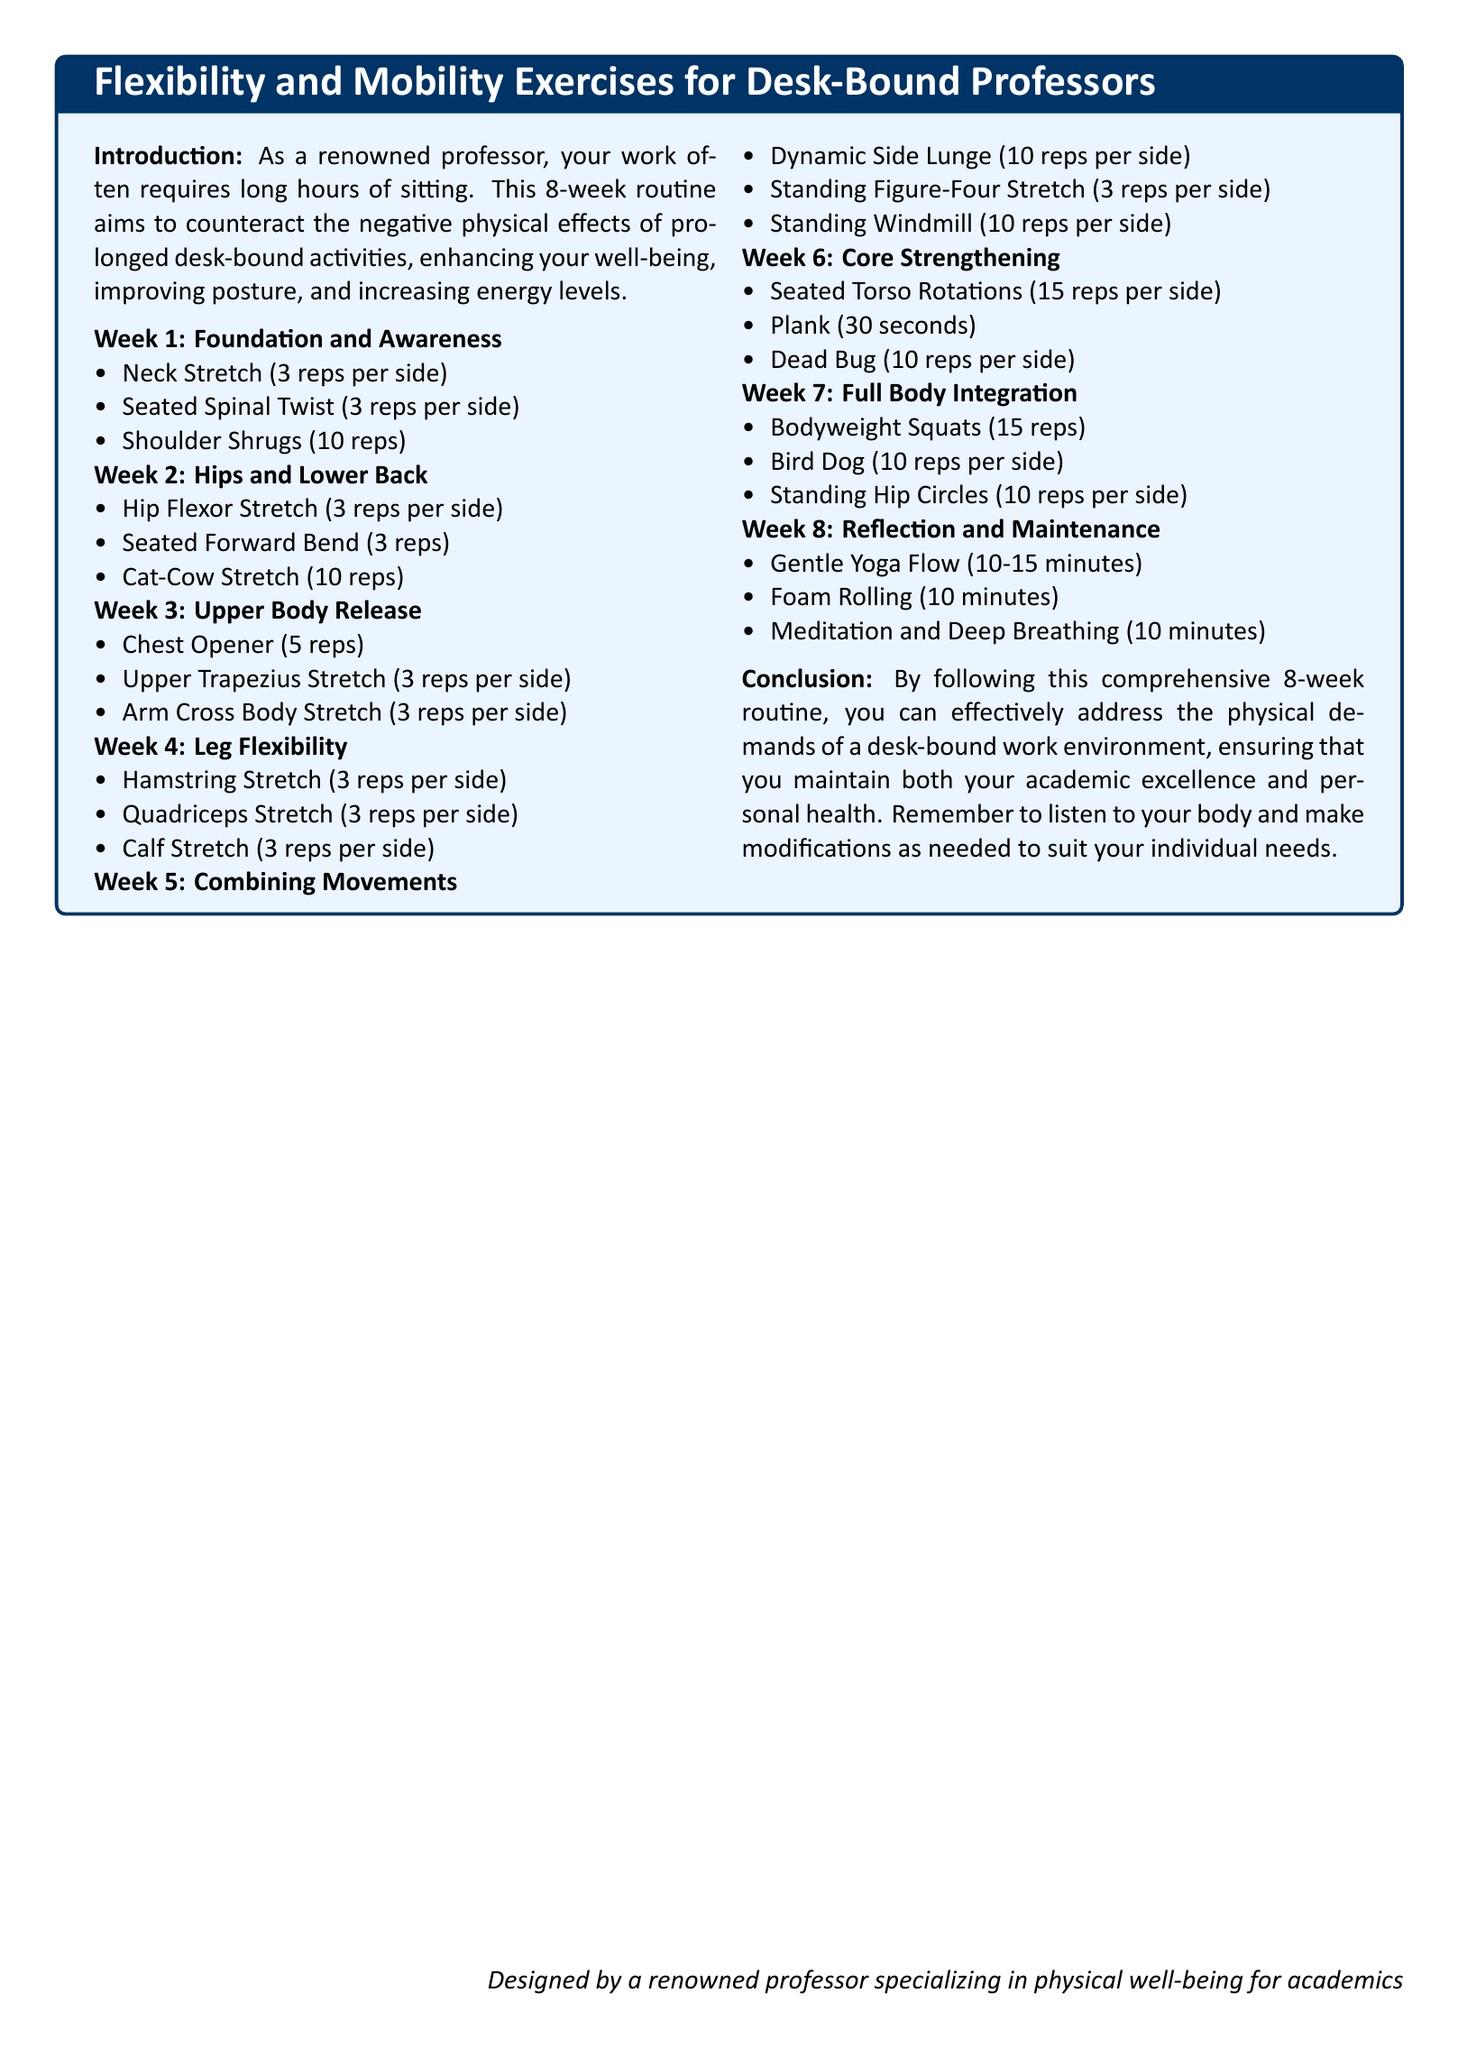What is the focus of the workout plan? The workout plan focuses on flexibility and mobility exercises for desk-bound professors.
Answer: Flexibility and mobility exercises How many weeks does the routine span? The document states that it is an 8-week routine.
Answer: 8 weeks What exercise is listed for Week 1? Week 1 includes the Neck Stretch as one of the exercises.
Answer: Neck Stretch How many reps are suggested for the Plank in Week 6? The Plank is suggested for a duration of 30 seconds in Week 6.
Answer: 30 seconds What is the main goal of the exercises in the plan? The main goal is to counteract negative physical effects of prolonged sitting.
Answer: Counteract negative physical effects of prolonged sitting Which week includes a Gentle Yoga Flow? The Gentle Yoga Flow is included in Week 8.
Answer: Week 8 What type of stretch is performed in Week 5? The Standing Figure-Four Stretch is performed in Week 5.
Answer: Standing Figure-Four Stretch What type of routine does the document describe? The document describes a comprehensive workout plan aimed at desk-bound individuals.
Answer: Comprehensive workout plan How many reps should be done for Shoulder Shrugs in Week 1? The exercise suggests doing 10 reps for Shoulder Shrugs in Week 1.
Answer: 10 reps 